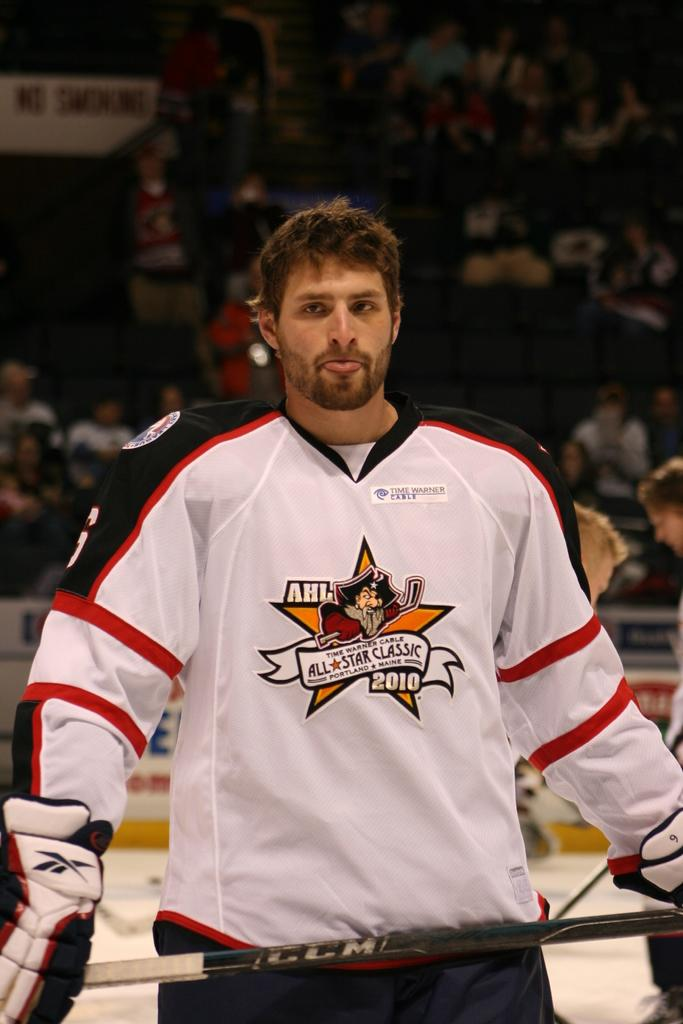<image>
Summarize the visual content of the image. a player that has the AHL written on his jersey 